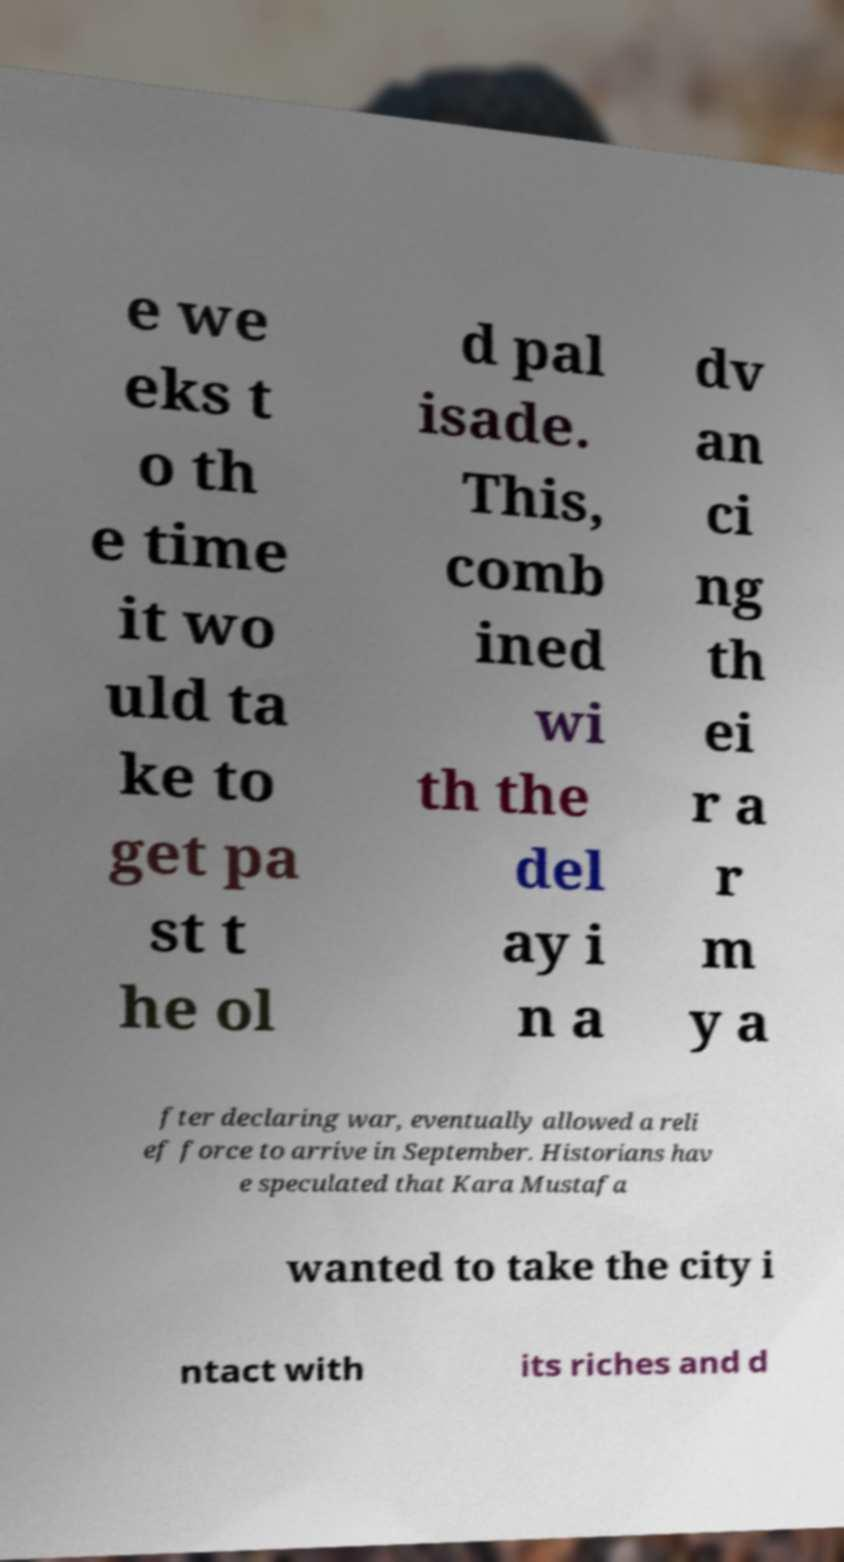Can you accurately transcribe the text from the provided image for me? e we eks t o th e time it wo uld ta ke to get pa st t he ol d pal isade. This, comb ined wi th the del ay i n a dv an ci ng th ei r a r m y a fter declaring war, eventually allowed a reli ef force to arrive in September. Historians hav e speculated that Kara Mustafa wanted to take the city i ntact with its riches and d 